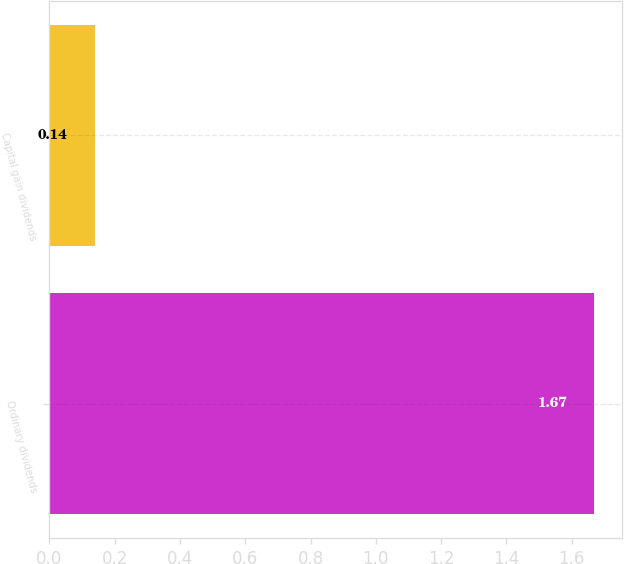Convert chart. <chart><loc_0><loc_0><loc_500><loc_500><bar_chart><fcel>Ordinary dividends<fcel>Capital gain dividends<nl><fcel>1.67<fcel>0.14<nl></chart> 